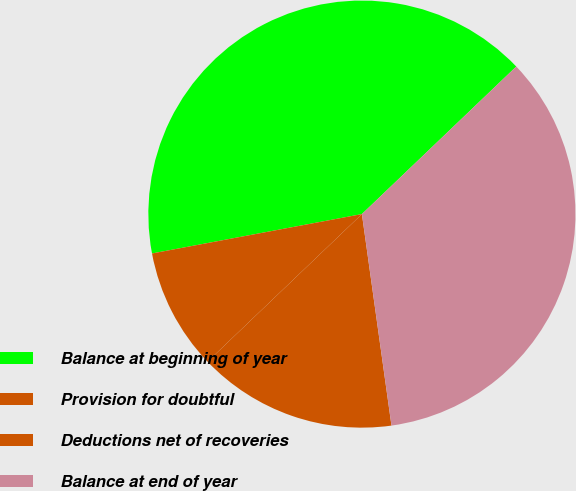<chart> <loc_0><loc_0><loc_500><loc_500><pie_chart><fcel>Balance at beginning of year<fcel>Provision for doubtful<fcel>Deductions net of recoveries<fcel>Balance at end of year<nl><fcel>40.81%<fcel>9.19%<fcel>15.07%<fcel>34.93%<nl></chart> 